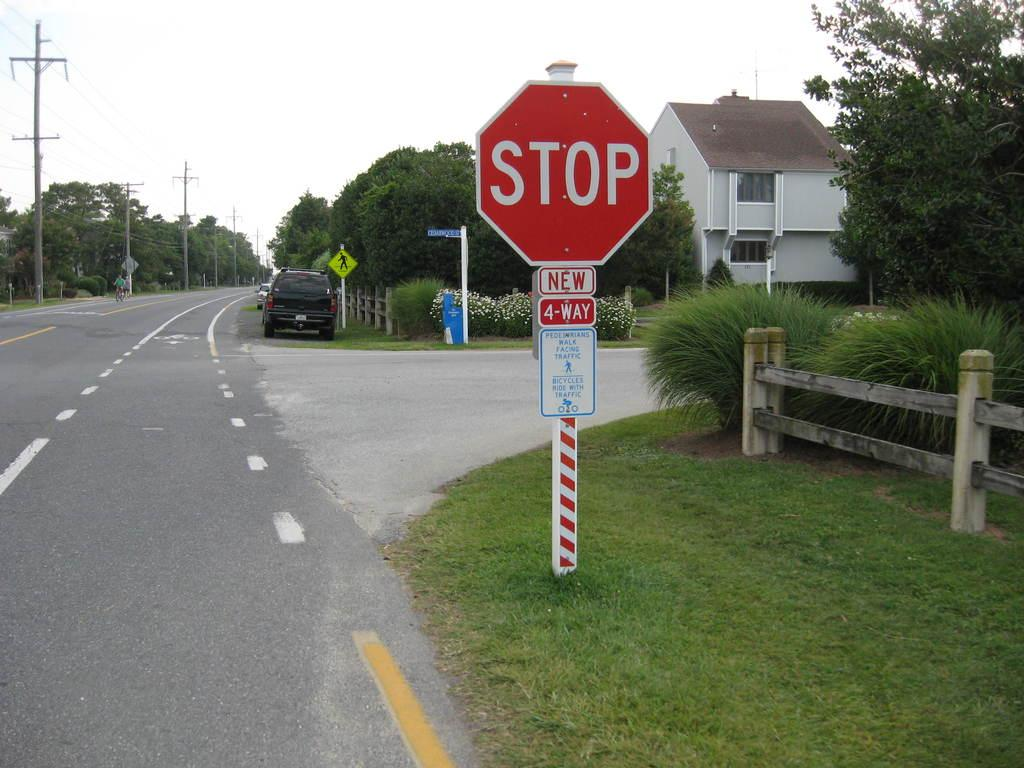<image>
Share a concise interpretation of the image provided. a stop sign that has the word new under it 